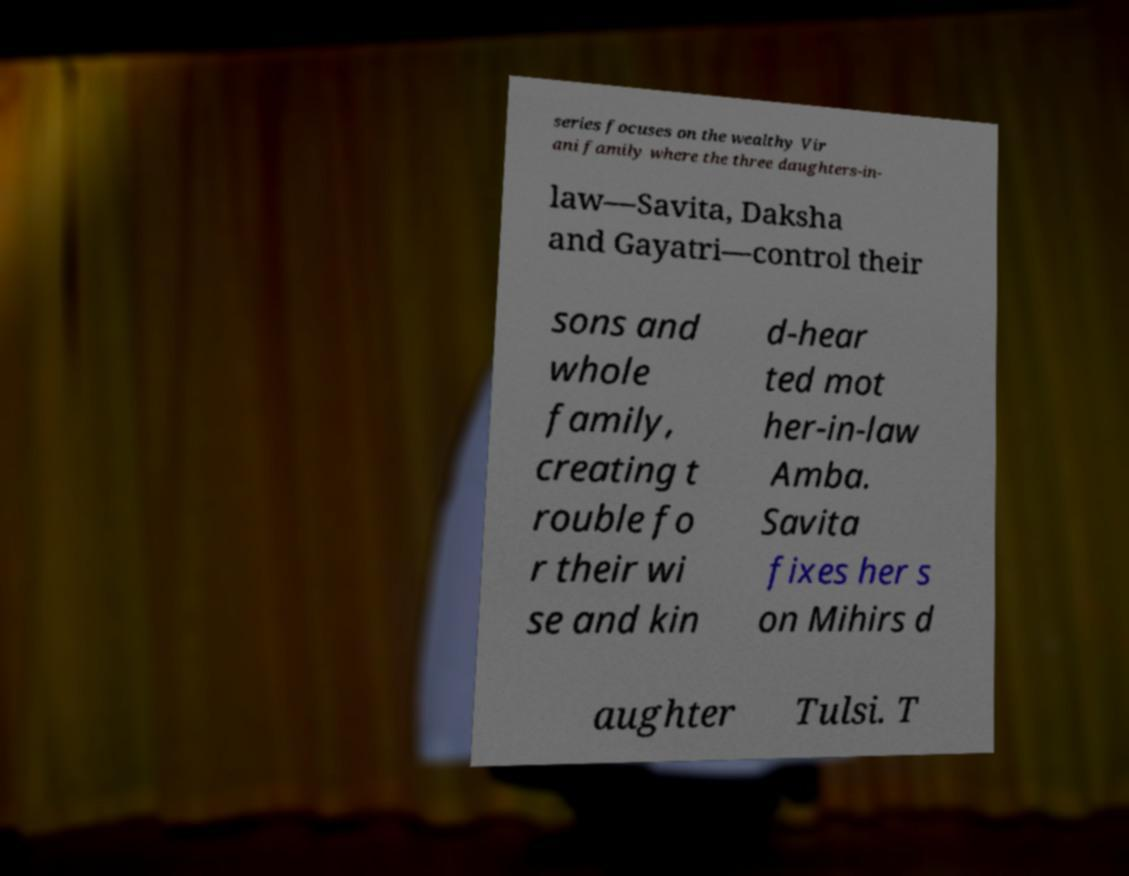I need the written content from this picture converted into text. Can you do that? series focuses on the wealthy Vir ani family where the three daughters-in- law—Savita, Daksha and Gayatri—control their sons and whole family, creating t rouble fo r their wi se and kin d-hear ted mot her-in-law Amba. Savita fixes her s on Mihirs d aughter Tulsi. T 